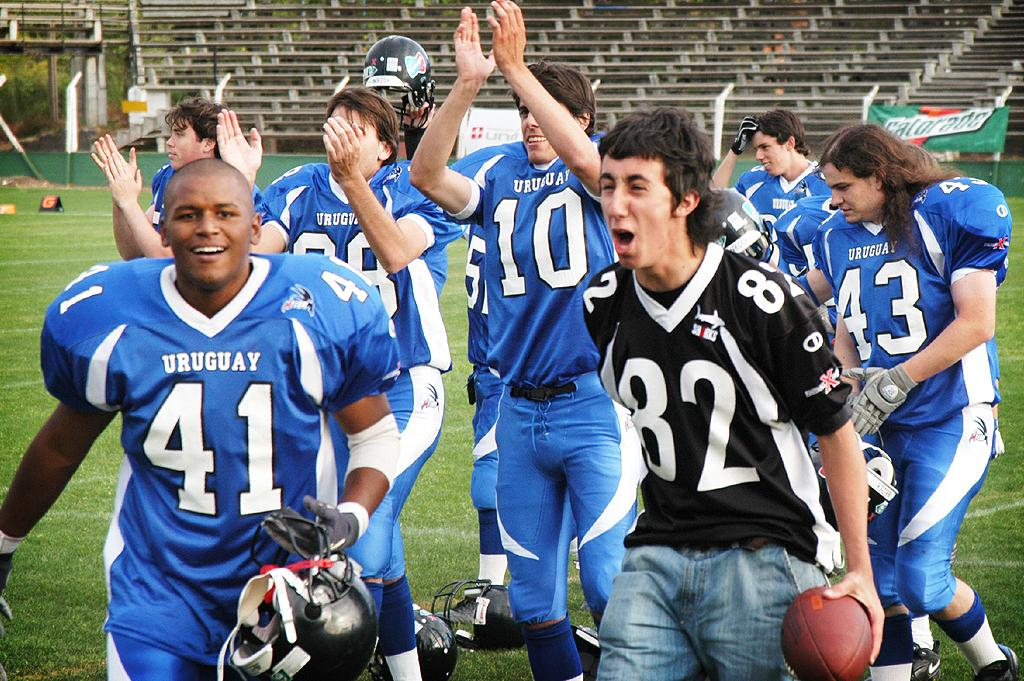What type of people can be seen in the image? There are sportspeople in the image. What is the man holding in the image? The man is holding a ball. What can be seen in the background of the image? There are boards visible in the background of the image. What type of seating is present in the image? There are benches in the image. What type of screw is being used to secure the voyage in the image? There is no mention of a voyage or screw in the image; it features sportspeople, a man holding a ball, boards in the background, and benches. 